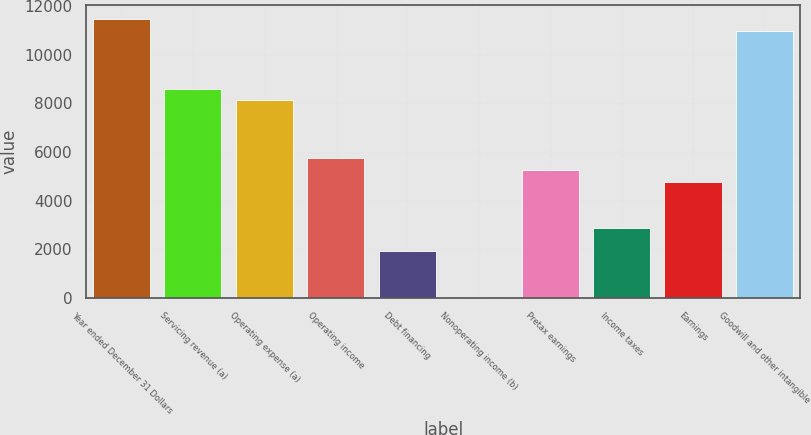Convert chart to OTSL. <chart><loc_0><loc_0><loc_500><loc_500><bar_chart><fcel>Year ended December 31 Dollars<fcel>Servicing revenue (a)<fcel>Operating expense (a)<fcel>Operating income<fcel>Debt financing<fcel>Nonoperating income (b)<fcel>Pretax earnings<fcel>Income taxes<fcel>Earnings<fcel>Goodwill and other intangible<nl><fcel>11473.2<fcel>8606.4<fcel>8128.6<fcel>5739.6<fcel>1917.2<fcel>6<fcel>5261.8<fcel>2872.8<fcel>4784<fcel>10995.4<nl></chart> 